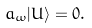Convert formula to latex. <formula><loc_0><loc_0><loc_500><loc_500>a _ { \omega } | U \rangle = 0 .</formula> 